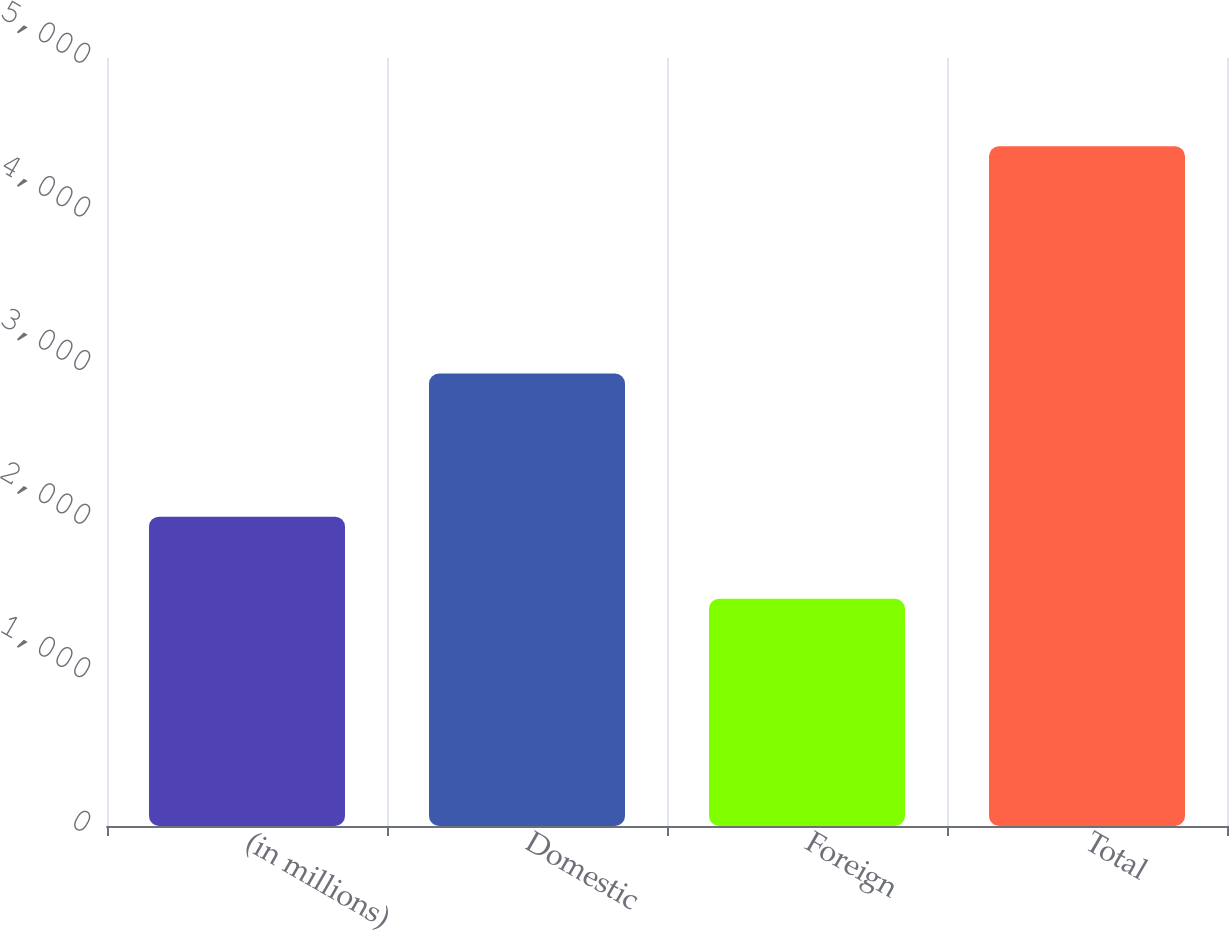<chart> <loc_0><loc_0><loc_500><loc_500><bar_chart><fcel>(in millions)<fcel>Domestic<fcel>Foreign<fcel>Total<nl><fcel>2014<fcel>2946<fcel>1479<fcel>4425<nl></chart> 